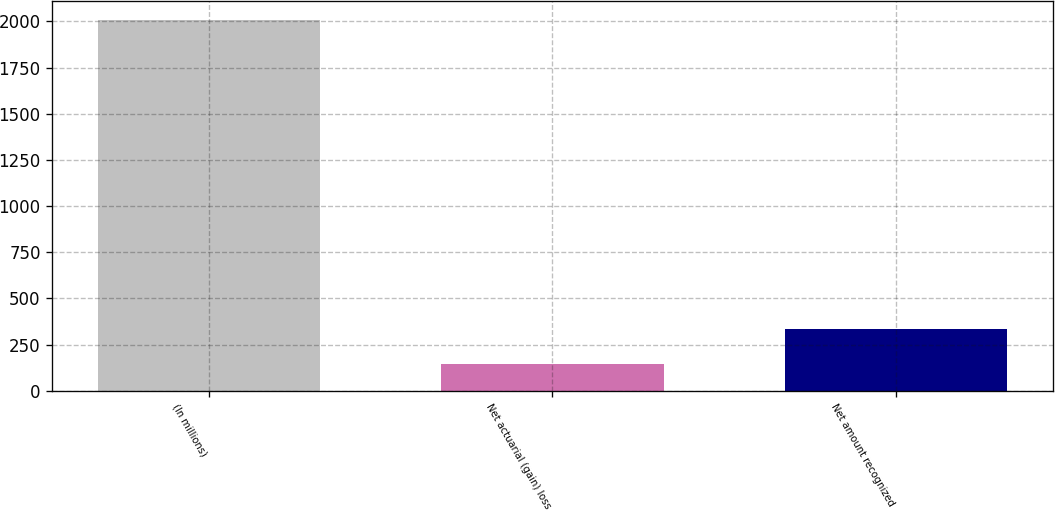Convert chart. <chart><loc_0><loc_0><loc_500><loc_500><bar_chart><fcel>(In millions)<fcel>Net actuarial (gain) loss<fcel>Net amount recognized<nl><fcel>2008<fcel>146.9<fcel>333.01<nl></chart> 